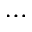<formula> <loc_0><loc_0><loc_500><loc_500>\cdots</formula> 